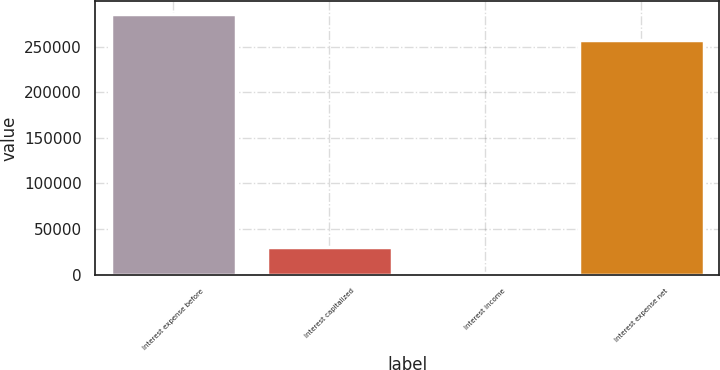Convert chart. <chart><loc_0><loc_0><loc_500><loc_500><bar_chart><fcel>Interest expense before<fcel>Interest capitalized<fcel>Interest income<fcel>Interest expense net<nl><fcel>285352<fcel>29890.5<fcel>1584<fcel>257045<nl></chart> 